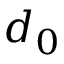Convert formula to latex. <formula><loc_0><loc_0><loc_500><loc_500>d _ { 0 }</formula> 